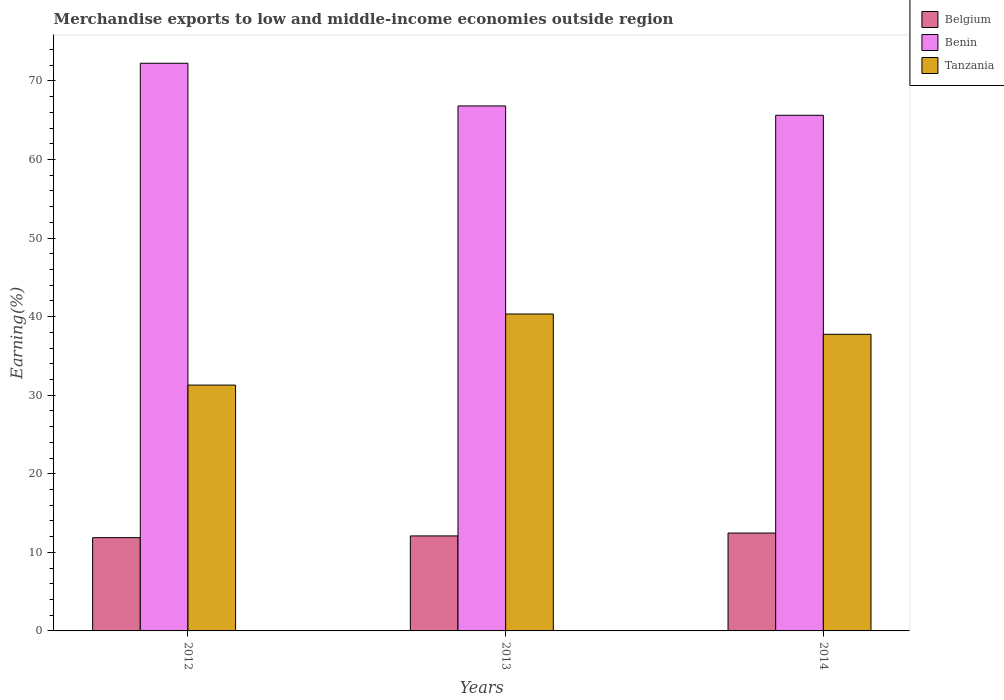Are the number of bars per tick equal to the number of legend labels?
Offer a terse response. Yes. In how many cases, is the number of bars for a given year not equal to the number of legend labels?
Ensure brevity in your answer.  0. What is the percentage of amount earned from merchandise exports in Benin in 2014?
Your response must be concise. 65.62. Across all years, what is the maximum percentage of amount earned from merchandise exports in Belgium?
Your answer should be compact. 12.46. Across all years, what is the minimum percentage of amount earned from merchandise exports in Benin?
Offer a very short reply. 65.62. What is the total percentage of amount earned from merchandise exports in Tanzania in the graph?
Make the answer very short. 109.37. What is the difference between the percentage of amount earned from merchandise exports in Benin in 2012 and that in 2014?
Keep it short and to the point. 6.62. What is the difference between the percentage of amount earned from merchandise exports in Benin in 2014 and the percentage of amount earned from merchandise exports in Belgium in 2013?
Offer a very short reply. 53.53. What is the average percentage of amount earned from merchandise exports in Belgium per year?
Provide a succinct answer. 12.14. In the year 2012, what is the difference between the percentage of amount earned from merchandise exports in Belgium and percentage of amount earned from merchandise exports in Tanzania?
Offer a very short reply. -19.42. In how many years, is the percentage of amount earned from merchandise exports in Tanzania greater than 56 %?
Your answer should be compact. 0. What is the ratio of the percentage of amount earned from merchandise exports in Belgium in 2013 to that in 2014?
Your answer should be very brief. 0.97. Is the percentage of amount earned from merchandise exports in Benin in 2013 less than that in 2014?
Offer a very short reply. No. What is the difference between the highest and the second highest percentage of amount earned from merchandise exports in Benin?
Your answer should be compact. 5.43. What is the difference between the highest and the lowest percentage of amount earned from merchandise exports in Belgium?
Provide a short and direct response. 0.59. What does the 1st bar from the left in 2013 represents?
Your response must be concise. Belgium. What does the 1st bar from the right in 2013 represents?
Give a very brief answer. Tanzania. Is it the case that in every year, the sum of the percentage of amount earned from merchandise exports in Tanzania and percentage of amount earned from merchandise exports in Benin is greater than the percentage of amount earned from merchandise exports in Belgium?
Your answer should be very brief. Yes. Does the graph contain grids?
Ensure brevity in your answer.  No. Where does the legend appear in the graph?
Give a very brief answer. Top right. How are the legend labels stacked?
Provide a short and direct response. Vertical. What is the title of the graph?
Give a very brief answer. Merchandise exports to low and middle-income economies outside region. What is the label or title of the X-axis?
Make the answer very short. Years. What is the label or title of the Y-axis?
Make the answer very short. Earning(%). What is the Earning(%) of Belgium in 2012?
Ensure brevity in your answer.  11.87. What is the Earning(%) of Benin in 2012?
Offer a terse response. 72.25. What is the Earning(%) of Tanzania in 2012?
Make the answer very short. 31.29. What is the Earning(%) in Belgium in 2013?
Provide a succinct answer. 12.09. What is the Earning(%) of Benin in 2013?
Keep it short and to the point. 66.81. What is the Earning(%) in Tanzania in 2013?
Your answer should be very brief. 40.33. What is the Earning(%) of Belgium in 2014?
Provide a short and direct response. 12.46. What is the Earning(%) of Benin in 2014?
Keep it short and to the point. 65.62. What is the Earning(%) of Tanzania in 2014?
Offer a very short reply. 37.75. Across all years, what is the maximum Earning(%) of Belgium?
Offer a terse response. 12.46. Across all years, what is the maximum Earning(%) of Benin?
Provide a short and direct response. 72.25. Across all years, what is the maximum Earning(%) of Tanzania?
Your answer should be very brief. 40.33. Across all years, what is the minimum Earning(%) in Belgium?
Provide a short and direct response. 11.87. Across all years, what is the minimum Earning(%) of Benin?
Keep it short and to the point. 65.62. Across all years, what is the minimum Earning(%) in Tanzania?
Your answer should be very brief. 31.29. What is the total Earning(%) in Belgium in the graph?
Give a very brief answer. 36.42. What is the total Earning(%) of Benin in the graph?
Offer a terse response. 204.68. What is the total Earning(%) in Tanzania in the graph?
Your answer should be compact. 109.37. What is the difference between the Earning(%) of Belgium in 2012 and that in 2013?
Provide a succinct answer. -0.22. What is the difference between the Earning(%) in Benin in 2012 and that in 2013?
Make the answer very short. 5.43. What is the difference between the Earning(%) in Tanzania in 2012 and that in 2013?
Provide a succinct answer. -9.05. What is the difference between the Earning(%) of Belgium in 2012 and that in 2014?
Give a very brief answer. -0.59. What is the difference between the Earning(%) in Benin in 2012 and that in 2014?
Offer a terse response. 6.62. What is the difference between the Earning(%) of Tanzania in 2012 and that in 2014?
Offer a terse response. -6.46. What is the difference between the Earning(%) of Belgium in 2013 and that in 2014?
Provide a succinct answer. -0.37. What is the difference between the Earning(%) of Benin in 2013 and that in 2014?
Your answer should be compact. 1.19. What is the difference between the Earning(%) of Tanzania in 2013 and that in 2014?
Provide a succinct answer. 2.58. What is the difference between the Earning(%) in Belgium in 2012 and the Earning(%) in Benin in 2013?
Provide a succinct answer. -54.94. What is the difference between the Earning(%) in Belgium in 2012 and the Earning(%) in Tanzania in 2013?
Ensure brevity in your answer.  -28.46. What is the difference between the Earning(%) in Benin in 2012 and the Earning(%) in Tanzania in 2013?
Ensure brevity in your answer.  31.91. What is the difference between the Earning(%) of Belgium in 2012 and the Earning(%) of Benin in 2014?
Your answer should be very brief. -53.75. What is the difference between the Earning(%) in Belgium in 2012 and the Earning(%) in Tanzania in 2014?
Your answer should be compact. -25.88. What is the difference between the Earning(%) of Benin in 2012 and the Earning(%) of Tanzania in 2014?
Make the answer very short. 34.5. What is the difference between the Earning(%) in Belgium in 2013 and the Earning(%) in Benin in 2014?
Your answer should be compact. -53.53. What is the difference between the Earning(%) of Belgium in 2013 and the Earning(%) of Tanzania in 2014?
Ensure brevity in your answer.  -25.66. What is the difference between the Earning(%) in Benin in 2013 and the Earning(%) in Tanzania in 2014?
Your answer should be very brief. 29.06. What is the average Earning(%) of Belgium per year?
Your response must be concise. 12.14. What is the average Earning(%) of Benin per year?
Provide a succinct answer. 68.23. What is the average Earning(%) of Tanzania per year?
Offer a very short reply. 36.46. In the year 2012, what is the difference between the Earning(%) of Belgium and Earning(%) of Benin?
Offer a terse response. -60.37. In the year 2012, what is the difference between the Earning(%) in Belgium and Earning(%) in Tanzania?
Ensure brevity in your answer.  -19.42. In the year 2012, what is the difference between the Earning(%) of Benin and Earning(%) of Tanzania?
Give a very brief answer. 40.96. In the year 2013, what is the difference between the Earning(%) in Belgium and Earning(%) in Benin?
Give a very brief answer. -54.72. In the year 2013, what is the difference between the Earning(%) in Belgium and Earning(%) in Tanzania?
Your answer should be very brief. -28.24. In the year 2013, what is the difference between the Earning(%) in Benin and Earning(%) in Tanzania?
Your response must be concise. 26.48. In the year 2014, what is the difference between the Earning(%) in Belgium and Earning(%) in Benin?
Your answer should be compact. -53.17. In the year 2014, what is the difference between the Earning(%) of Belgium and Earning(%) of Tanzania?
Your answer should be very brief. -25.29. In the year 2014, what is the difference between the Earning(%) of Benin and Earning(%) of Tanzania?
Offer a terse response. 27.88. What is the ratio of the Earning(%) in Belgium in 2012 to that in 2013?
Your answer should be compact. 0.98. What is the ratio of the Earning(%) of Benin in 2012 to that in 2013?
Your answer should be very brief. 1.08. What is the ratio of the Earning(%) of Tanzania in 2012 to that in 2013?
Provide a succinct answer. 0.78. What is the ratio of the Earning(%) of Belgium in 2012 to that in 2014?
Make the answer very short. 0.95. What is the ratio of the Earning(%) in Benin in 2012 to that in 2014?
Make the answer very short. 1.1. What is the ratio of the Earning(%) of Tanzania in 2012 to that in 2014?
Provide a succinct answer. 0.83. What is the ratio of the Earning(%) of Belgium in 2013 to that in 2014?
Your answer should be very brief. 0.97. What is the ratio of the Earning(%) of Benin in 2013 to that in 2014?
Offer a very short reply. 1.02. What is the ratio of the Earning(%) of Tanzania in 2013 to that in 2014?
Give a very brief answer. 1.07. What is the difference between the highest and the second highest Earning(%) in Belgium?
Ensure brevity in your answer.  0.37. What is the difference between the highest and the second highest Earning(%) of Benin?
Provide a short and direct response. 5.43. What is the difference between the highest and the second highest Earning(%) of Tanzania?
Give a very brief answer. 2.58. What is the difference between the highest and the lowest Earning(%) in Belgium?
Provide a succinct answer. 0.59. What is the difference between the highest and the lowest Earning(%) in Benin?
Keep it short and to the point. 6.62. What is the difference between the highest and the lowest Earning(%) in Tanzania?
Give a very brief answer. 9.05. 